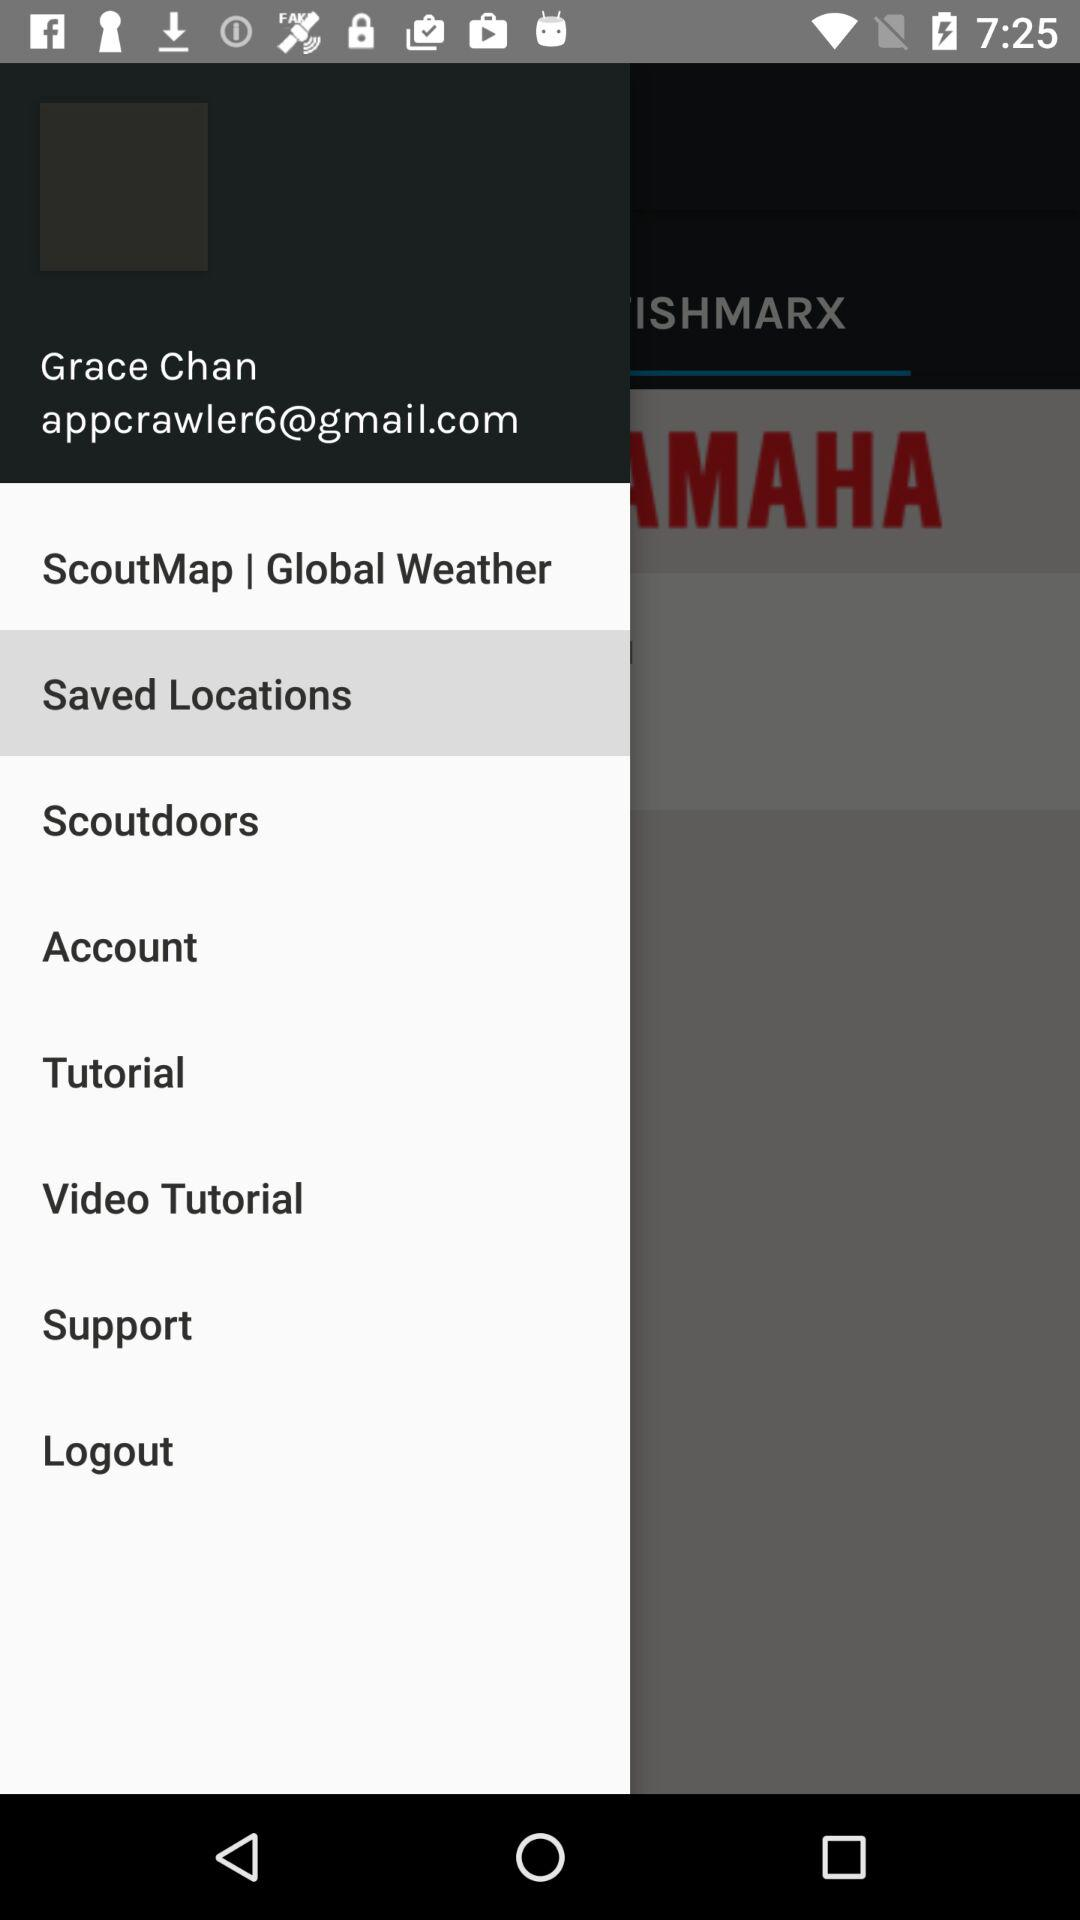What is the email address? The email address is appcrawler6@gmail.com. 